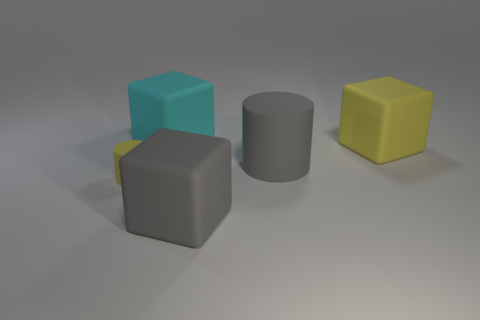There is another object that is the same shape as the tiny rubber object; what material is it?
Your answer should be compact. Rubber. There is a large matte thing that is in front of the small rubber thing; is it the same color as the small cylinder?
Offer a very short reply. No. There is another object that is the same shape as the small thing; what color is it?
Ensure brevity in your answer.  Gray. How many big things are either yellow cubes or cyan metallic cylinders?
Your answer should be compact. 1. What is the size of the matte cylinder on the left side of the large gray rubber cylinder?
Your answer should be very brief. Small. Is there a matte cube that has the same color as the tiny cylinder?
Offer a terse response. Yes. Is the color of the big rubber cylinder the same as the tiny matte object?
Provide a succinct answer. No. The large object that is the same color as the big rubber cylinder is what shape?
Give a very brief answer. Cube. What number of tiny matte objects are in front of the cylinder that is behind the tiny yellow cylinder?
Give a very brief answer. 1. What number of small objects are made of the same material as the yellow cube?
Your answer should be compact. 1. 